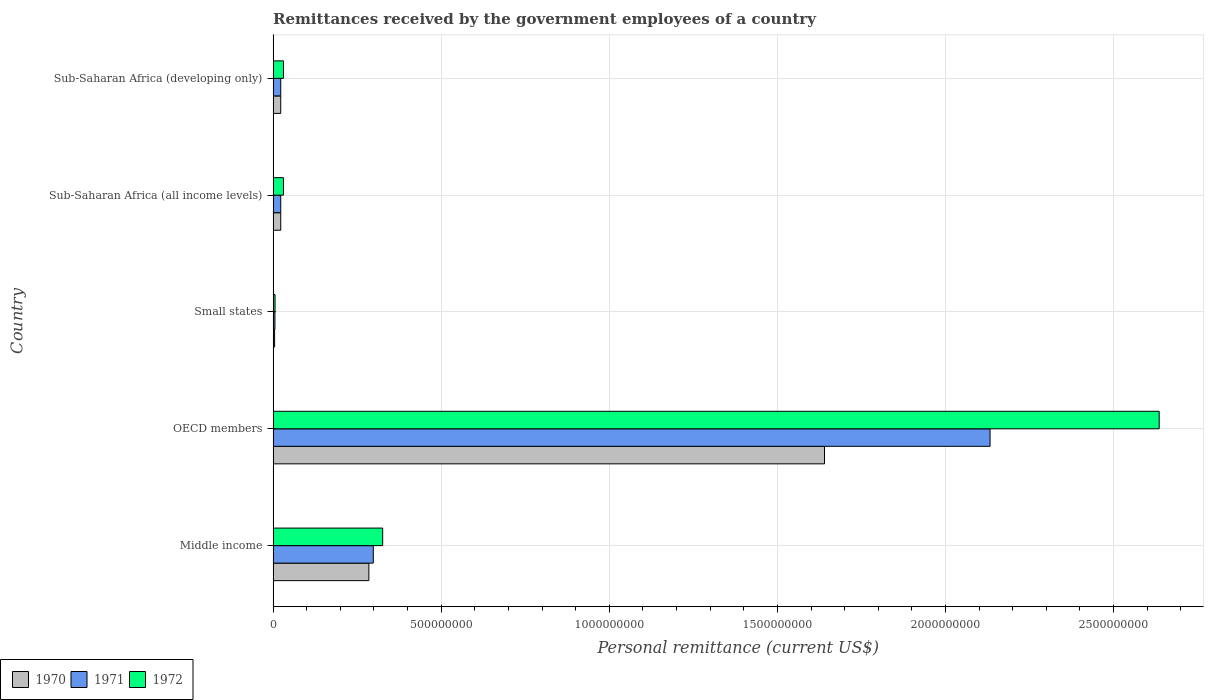How many different coloured bars are there?
Offer a very short reply. 3. Are the number of bars on each tick of the Y-axis equal?
Make the answer very short. Yes. How many bars are there on the 4th tick from the top?
Ensure brevity in your answer.  3. What is the label of the 4th group of bars from the top?
Give a very brief answer. OECD members. What is the remittances received by the government employees in 1970 in Sub-Saharan Africa (developing only)?
Your answer should be very brief. 2.27e+07. Across all countries, what is the maximum remittances received by the government employees in 1971?
Make the answer very short. 2.13e+09. Across all countries, what is the minimum remittances received by the government employees in 1972?
Make the answer very short. 5.71e+06. In which country was the remittances received by the government employees in 1972 maximum?
Offer a terse response. OECD members. In which country was the remittances received by the government employees in 1970 minimum?
Ensure brevity in your answer.  Small states. What is the total remittances received by the government employees in 1972 in the graph?
Keep it short and to the point. 3.03e+09. What is the difference between the remittances received by the government employees in 1970 in Middle income and that in Sub-Saharan Africa (developing only)?
Provide a succinct answer. 2.62e+08. What is the difference between the remittances received by the government employees in 1970 in Small states and the remittances received by the government employees in 1971 in OECD members?
Keep it short and to the point. -2.13e+09. What is the average remittances received by the government employees in 1971 per country?
Offer a very short reply. 4.96e+08. What is the difference between the remittances received by the government employees in 1970 and remittances received by the government employees in 1972 in Middle income?
Your response must be concise. -4.11e+07. In how many countries, is the remittances received by the government employees in 1972 greater than 2400000000 US$?
Provide a succinct answer. 1. What is the ratio of the remittances received by the government employees in 1970 in Middle income to that in Sub-Saharan Africa (developing only)?
Offer a terse response. 12.57. Is the remittances received by the government employees in 1972 in Small states less than that in Sub-Saharan Africa (all income levels)?
Offer a very short reply. Yes. What is the difference between the highest and the second highest remittances received by the government employees in 1971?
Your answer should be compact. 1.83e+09. What is the difference between the highest and the lowest remittances received by the government employees in 1971?
Ensure brevity in your answer.  2.13e+09. In how many countries, is the remittances received by the government employees in 1972 greater than the average remittances received by the government employees in 1972 taken over all countries?
Your answer should be very brief. 1. What does the 2nd bar from the bottom in Sub-Saharan Africa (developing only) represents?
Ensure brevity in your answer.  1971. Is it the case that in every country, the sum of the remittances received by the government employees in 1971 and remittances received by the government employees in 1972 is greater than the remittances received by the government employees in 1970?
Ensure brevity in your answer.  Yes. Are all the bars in the graph horizontal?
Provide a succinct answer. Yes. Does the graph contain grids?
Make the answer very short. Yes. What is the title of the graph?
Make the answer very short. Remittances received by the government employees of a country. Does "1975" appear as one of the legend labels in the graph?
Make the answer very short. No. What is the label or title of the X-axis?
Your answer should be compact. Personal remittance (current US$). What is the label or title of the Y-axis?
Make the answer very short. Country. What is the Personal remittance (current US$) in 1970 in Middle income?
Your answer should be very brief. 2.85e+08. What is the Personal remittance (current US$) of 1971 in Middle income?
Provide a short and direct response. 2.98e+08. What is the Personal remittance (current US$) in 1972 in Middle income?
Your answer should be very brief. 3.26e+08. What is the Personal remittance (current US$) of 1970 in OECD members?
Give a very brief answer. 1.64e+09. What is the Personal remittance (current US$) in 1971 in OECD members?
Provide a succinct answer. 2.13e+09. What is the Personal remittance (current US$) in 1972 in OECD members?
Keep it short and to the point. 2.64e+09. What is the Personal remittance (current US$) of 1970 in Small states?
Provide a succinct answer. 4.40e+06. What is the Personal remittance (current US$) of 1971 in Small states?
Keep it short and to the point. 5.40e+06. What is the Personal remittance (current US$) in 1972 in Small states?
Your response must be concise. 5.71e+06. What is the Personal remittance (current US$) in 1970 in Sub-Saharan Africa (all income levels)?
Your answer should be compact. 2.27e+07. What is the Personal remittance (current US$) of 1971 in Sub-Saharan Africa (all income levels)?
Give a very brief answer. 2.26e+07. What is the Personal remittance (current US$) in 1972 in Sub-Saharan Africa (all income levels)?
Give a very brief answer. 3.07e+07. What is the Personal remittance (current US$) of 1970 in Sub-Saharan Africa (developing only)?
Offer a terse response. 2.27e+07. What is the Personal remittance (current US$) in 1971 in Sub-Saharan Africa (developing only)?
Give a very brief answer. 2.26e+07. What is the Personal remittance (current US$) in 1972 in Sub-Saharan Africa (developing only)?
Your answer should be compact. 3.07e+07. Across all countries, what is the maximum Personal remittance (current US$) in 1970?
Provide a short and direct response. 1.64e+09. Across all countries, what is the maximum Personal remittance (current US$) in 1971?
Give a very brief answer. 2.13e+09. Across all countries, what is the maximum Personal remittance (current US$) of 1972?
Offer a terse response. 2.64e+09. Across all countries, what is the minimum Personal remittance (current US$) of 1970?
Ensure brevity in your answer.  4.40e+06. Across all countries, what is the minimum Personal remittance (current US$) in 1971?
Your response must be concise. 5.40e+06. Across all countries, what is the minimum Personal remittance (current US$) in 1972?
Keep it short and to the point. 5.71e+06. What is the total Personal remittance (current US$) in 1970 in the graph?
Keep it short and to the point. 1.97e+09. What is the total Personal remittance (current US$) in 1971 in the graph?
Provide a short and direct response. 2.48e+09. What is the total Personal remittance (current US$) in 1972 in the graph?
Make the answer very short. 3.03e+09. What is the difference between the Personal remittance (current US$) of 1970 in Middle income and that in OECD members?
Provide a short and direct response. -1.36e+09. What is the difference between the Personal remittance (current US$) in 1971 in Middle income and that in OECD members?
Your answer should be compact. -1.83e+09. What is the difference between the Personal remittance (current US$) of 1972 in Middle income and that in OECD members?
Ensure brevity in your answer.  -2.31e+09. What is the difference between the Personal remittance (current US$) in 1970 in Middle income and that in Small states?
Your answer should be very brief. 2.80e+08. What is the difference between the Personal remittance (current US$) in 1971 in Middle income and that in Small states?
Offer a very short reply. 2.93e+08. What is the difference between the Personal remittance (current US$) of 1972 in Middle income and that in Small states?
Provide a short and direct response. 3.20e+08. What is the difference between the Personal remittance (current US$) in 1970 in Middle income and that in Sub-Saharan Africa (all income levels)?
Provide a succinct answer. 2.62e+08. What is the difference between the Personal remittance (current US$) in 1971 in Middle income and that in Sub-Saharan Africa (all income levels)?
Your answer should be very brief. 2.75e+08. What is the difference between the Personal remittance (current US$) of 1972 in Middle income and that in Sub-Saharan Africa (all income levels)?
Make the answer very short. 2.95e+08. What is the difference between the Personal remittance (current US$) of 1970 in Middle income and that in Sub-Saharan Africa (developing only)?
Keep it short and to the point. 2.62e+08. What is the difference between the Personal remittance (current US$) of 1971 in Middle income and that in Sub-Saharan Africa (developing only)?
Keep it short and to the point. 2.75e+08. What is the difference between the Personal remittance (current US$) of 1972 in Middle income and that in Sub-Saharan Africa (developing only)?
Give a very brief answer. 2.95e+08. What is the difference between the Personal remittance (current US$) of 1970 in OECD members and that in Small states?
Provide a short and direct response. 1.64e+09. What is the difference between the Personal remittance (current US$) in 1971 in OECD members and that in Small states?
Make the answer very short. 2.13e+09. What is the difference between the Personal remittance (current US$) of 1972 in OECD members and that in Small states?
Provide a succinct answer. 2.63e+09. What is the difference between the Personal remittance (current US$) in 1970 in OECD members and that in Sub-Saharan Africa (all income levels)?
Make the answer very short. 1.62e+09. What is the difference between the Personal remittance (current US$) of 1971 in OECD members and that in Sub-Saharan Africa (all income levels)?
Offer a very short reply. 2.11e+09. What is the difference between the Personal remittance (current US$) in 1972 in OECD members and that in Sub-Saharan Africa (all income levels)?
Keep it short and to the point. 2.60e+09. What is the difference between the Personal remittance (current US$) in 1970 in OECD members and that in Sub-Saharan Africa (developing only)?
Your answer should be compact. 1.62e+09. What is the difference between the Personal remittance (current US$) in 1971 in OECD members and that in Sub-Saharan Africa (developing only)?
Make the answer very short. 2.11e+09. What is the difference between the Personal remittance (current US$) of 1972 in OECD members and that in Sub-Saharan Africa (developing only)?
Make the answer very short. 2.60e+09. What is the difference between the Personal remittance (current US$) of 1970 in Small states and that in Sub-Saharan Africa (all income levels)?
Your answer should be very brief. -1.83e+07. What is the difference between the Personal remittance (current US$) of 1971 in Small states and that in Sub-Saharan Africa (all income levels)?
Ensure brevity in your answer.  -1.72e+07. What is the difference between the Personal remittance (current US$) in 1972 in Small states and that in Sub-Saharan Africa (all income levels)?
Make the answer very short. -2.50e+07. What is the difference between the Personal remittance (current US$) in 1970 in Small states and that in Sub-Saharan Africa (developing only)?
Offer a very short reply. -1.83e+07. What is the difference between the Personal remittance (current US$) of 1971 in Small states and that in Sub-Saharan Africa (developing only)?
Make the answer very short. -1.72e+07. What is the difference between the Personal remittance (current US$) of 1972 in Small states and that in Sub-Saharan Africa (developing only)?
Offer a terse response. -2.50e+07. What is the difference between the Personal remittance (current US$) in 1971 in Sub-Saharan Africa (all income levels) and that in Sub-Saharan Africa (developing only)?
Make the answer very short. 0. What is the difference between the Personal remittance (current US$) of 1970 in Middle income and the Personal remittance (current US$) of 1971 in OECD members?
Keep it short and to the point. -1.85e+09. What is the difference between the Personal remittance (current US$) in 1970 in Middle income and the Personal remittance (current US$) in 1972 in OECD members?
Offer a very short reply. -2.35e+09. What is the difference between the Personal remittance (current US$) of 1971 in Middle income and the Personal remittance (current US$) of 1972 in OECD members?
Your answer should be compact. -2.34e+09. What is the difference between the Personal remittance (current US$) in 1970 in Middle income and the Personal remittance (current US$) in 1971 in Small states?
Give a very brief answer. 2.79e+08. What is the difference between the Personal remittance (current US$) of 1970 in Middle income and the Personal remittance (current US$) of 1972 in Small states?
Your answer should be compact. 2.79e+08. What is the difference between the Personal remittance (current US$) in 1971 in Middle income and the Personal remittance (current US$) in 1972 in Small states?
Keep it short and to the point. 2.92e+08. What is the difference between the Personal remittance (current US$) of 1970 in Middle income and the Personal remittance (current US$) of 1971 in Sub-Saharan Africa (all income levels)?
Your answer should be very brief. 2.62e+08. What is the difference between the Personal remittance (current US$) in 1970 in Middle income and the Personal remittance (current US$) in 1972 in Sub-Saharan Africa (all income levels)?
Your response must be concise. 2.54e+08. What is the difference between the Personal remittance (current US$) in 1971 in Middle income and the Personal remittance (current US$) in 1972 in Sub-Saharan Africa (all income levels)?
Ensure brevity in your answer.  2.67e+08. What is the difference between the Personal remittance (current US$) in 1970 in Middle income and the Personal remittance (current US$) in 1971 in Sub-Saharan Africa (developing only)?
Keep it short and to the point. 2.62e+08. What is the difference between the Personal remittance (current US$) of 1970 in Middle income and the Personal remittance (current US$) of 1972 in Sub-Saharan Africa (developing only)?
Provide a succinct answer. 2.54e+08. What is the difference between the Personal remittance (current US$) of 1971 in Middle income and the Personal remittance (current US$) of 1972 in Sub-Saharan Africa (developing only)?
Your response must be concise. 2.67e+08. What is the difference between the Personal remittance (current US$) in 1970 in OECD members and the Personal remittance (current US$) in 1971 in Small states?
Provide a short and direct response. 1.63e+09. What is the difference between the Personal remittance (current US$) in 1970 in OECD members and the Personal remittance (current US$) in 1972 in Small states?
Provide a succinct answer. 1.63e+09. What is the difference between the Personal remittance (current US$) in 1971 in OECD members and the Personal remittance (current US$) in 1972 in Small states?
Provide a short and direct response. 2.13e+09. What is the difference between the Personal remittance (current US$) in 1970 in OECD members and the Personal remittance (current US$) in 1971 in Sub-Saharan Africa (all income levels)?
Your response must be concise. 1.62e+09. What is the difference between the Personal remittance (current US$) of 1970 in OECD members and the Personal remittance (current US$) of 1972 in Sub-Saharan Africa (all income levels)?
Your response must be concise. 1.61e+09. What is the difference between the Personal remittance (current US$) of 1971 in OECD members and the Personal remittance (current US$) of 1972 in Sub-Saharan Africa (all income levels)?
Ensure brevity in your answer.  2.10e+09. What is the difference between the Personal remittance (current US$) of 1970 in OECD members and the Personal remittance (current US$) of 1971 in Sub-Saharan Africa (developing only)?
Your answer should be very brief. 1.62e+09. What is the difference between the Personal remittance (current US$) of 1970 in OECD members and the Personal remittance (current US$) of 1972 in Sub-Saharan Africa (developing only)?
Make the answer very short. 1.61e+09. What is the difference between the Personal remittance (current US$) of 1971 in OECD members and the Personal remittance (current US$) of 1972 in Sub-Saharan Africa (developing only)?
Make the answer very short. 2.10e+09. What is the difference between the Personal remittance (current US$) in 1970 in Small states and the Personal remittance (current US$) in 1971 in Sub-Saharan Africa (all income levels)?
Give a very brief answer. -1.82e+07. What is the difference between the Personal remittance (current US$) of 1970 in Small states and the Personal remittance (current US$) of 1972 in Sub-Saharan Africa (all income levels)?
Give a very brief answer. -2.63e+07. What is the difference between the Personal remittance (current US$) of 1971 in Small states and the Personal remittance (current US$) of 1972 in Sub-Saharan Africa (all income levels)?
Offer a terse response. -2.53e+07. What is the difference between the Personal remittance (current US$) in 1970 in Small states and the Personal remittance (current US$) in 1971 in Sub-Saharan Africa (developing only)?
Offer a terse response. -1.82e+07. What is the difference between the Personal remittance (current US$) in 1970 in Small states and the Personal remittance (current US$) in 1972 in Sub-Saharan Africa (developing only)?
Your answer should be compact. -2.63e+07. What is the difference between the Personal remittance (current US$) of 1971 in Small states and the Personal remittance (current US$) of 1972 in Sub-Saharan Africa (developing only)?
Your answer should be very brief. -2.53e+07. What is the difference between the Personal remittance (current US$) of 1970 in Sub-Saharan Africa (all income levels) and the Personal remittance (current US$) of 1971 in Sub-Saharan Africa (developing only)?
Your answer should be compact. 2.18e+04. What is the difference between the Personal remittance (current US$) in 1970 in Sub-Saharan Africa (all income levels) and the Personal remittance (current US$) in 1972 in Sub-Saharan Africa (developing only)?
Make the answer very short. -8.07e+06. What is the difference between the Personal remittance (current US$) in 1971 in Sub-Saharan Africa (all income levels) and the Personal remittance (current US$) in 1972 in Sub-Saharan Africa (developing only)?
Offer a terse response. -8.09e+06. What is the average Personal remittance (current US$) of 1970 per country?
Give a very brief answer. 3.95e+08. What is the average Personal remittance (current US$) in 1971 per country?
Your answer should be very brief. 4.96e+08. What is the average Personal remittance (current US$) in 1972 per country?
Keep it short and to the point. 6.06e+08. What is the difference between the Personal remittance (current US$) of 1970 and Personal remittance (current US$) of 1971 in Middle income?
Make the answer very short. -1.32e+07. What is the difference between the Personal remittance (current US$) of 1970 and Personal remittance (current US$) of 1972 in Middle income?
Offer a terse response. -4.11e+07. What is the difference between the Personal remittance (current US$) in 1971 and Personal remittance (current US$) in 1972 in Middle income?
Give a very brief answer. -2.79e+07. What is the difference between the Personal remittance (current US$) in 1970 and Personal remittance (current US$) in 1971 in OECD members?
Offer a terse response. -4.92e+08. What is the difference between the Personal remittance (current US$) in 1970 and Personal remittance (current US$) in 1972 in OECD members?
Provide a succinct answer. -9.96e+08. What is the difference between the Personal remittance (current US$) of 1971 and Personal remittance (current US$) of 1972 in OECD members?
Offer a very short reply. -5.03e+08. What is the difference between the Personal remittance (current US$) in 1970 and Personal remittance (current US$) in 1971 in Small states?
Make the answer very short. -1.00e+06. What is the difference between the Personal remittance (current US$) in 1970 and Personal remittance (current US$) in 1972 in Small states?
Give a very brief answer. -1.31e+06. What is the difference between the Personal remittance (current US$) in 1971 and Personal remittance (current US$) in 1972 in Small states?
Give a very brief answer. -3.07e+05. What is the difference between the Personal remittance (current US$) in 1970 and Personal remittance (current US$) in 1971 in Sub-Saharan Africa (all income levels)?
Your answer should be very brief. 2.18e+04. What is the difference between the Personal remittance (current US$) of 1970 and Personal remittance (current US$) of 1972 in Sub-Saharan Africa (all income levels)?
Offer a terse response. -8.07e+06. What is the difference between the Personal remittance (current US$) in 1971 and Personal remittance (current US$) in 1972 in Sub-Saharan Africa (all income levels)?
Provide a short and direct response. -8.09e+06. What is the difference between the Personal remittance (current US$) in 1970 and Personal remittance (current US$) in 1971 in Sub-Saharan Africa (developing only)?
Give a very brief answer. 2.18e+04. What is the difference between the Personal remittance (current US$) of 1970 and Personal remittance (current US$) of 1972 in Sub-Saharan Africa (developing only)?
Ensure brevity in your answer.  -8.07e+06. What is the difference between the Personal remittance (current US$) of 1971 and Personal remittance (current US$) of 1972 in Sub-Saharan Africa (developing only)?
Offer a terse response. -8.09e+06. What is the ratio of the Personal remittance (current US$) of 1970 in Middle income to that in OECD members?
Provide a short and direct response. 0.17. What is the ratio of the Personal remittance (current US$) of 1971 in Middle income to that in OECD members?
Give a very brief answer. 0.14. What is the ratio of the Personal remittance (current US$) in 1972 in Middle income to that in OECD members?
Ensure brevity in your answer.  0.12. What is the ratio of the Personal remittance (current US$) of 1970 in Middle income to that in Small states?
Keep it short and to the point. 64.72. What is the ratio of the Personal remittance (current US$) of 1971 in Middle income to that in Small states?
Provide a succinct answer. 55.17. What is the ratio of the Personal remittance (current US$) in 1972 in Middle income to that in Small states?
Keep it short and to the point. 57.08. What is the ratio of the Personal remittance (current US$) of 1970 in Middle income to that in Sub-Saharan Africa (all income levels)?
Keep it short and to the point. 12.57. What is the ratio of the Personal remittance (current US$) of 1971 in Middle income to that in Sub-Saharan Africa (all income levels)?
Give a very brief answer. 13.16. What is the ratio of the Personal remittance (current US$) of 1972 in Middle income to that in Sub-Saharan Africa (all income levels)?
Your answer should be compact. 10.6. What is the ratio of the Personal remittance (current US$) of 1970 in Middle income to that in Sub-Saharan Africa (developing only)?
Your answer should be very brief. 12.57. What is the ratio of the Personal remittance (current US$) of 1971 in Middle income to that in Sub-Saharan Africa (developing only)?
Offer a terse response. 13.16. What is the ratio of the Personal remittance (current US$) of 1972 in Middle income to that in Sub-Saharan Africa (developing only)?
Provide a short and direct response. 10.6. What is the ratio of the Personal remittance (current US$) in 1970 in OECD members to that in Small states?
Make the answer very short. 372.75. What is the ratio of the Personal remittance (current US$) in 1971 in OECD members to that in Small states?
Your response must be concise. 394.8. What is the ratio of the Personal remittance (current US$) of 1972 in OECD members to that in Small states?
Ensure brevity in your answer.  461.7. What is the ratio of the Personal remittance (current US$) of 1970 in OECD members to that in Sub-Saharan Africa (all income levels)?
Offer a terse response. 72.38. What is the ratio of the Personal remittance (current US$) in 1971 in OECD members to that in Sub-Saharan Africa (all income levels)?
Provide a succinct answer. 94.2. What is the ratio of the Personal remittance (current US$) of 1972 in OECD members to that in Sub-Saharan Africa (all income levels)?
Ensure brevity in your answer.  85.76. What is the ratio of the Personal remittance (current US$) of 1970 in OECD members to that in Sub-Saharan Africa (developing only)?
Keep it short and to the point. 72.38. What is the ratio of the Personal remittance (current US$) in 1971 in OECD members to that in Sub-Saharan Africa (developing only)?
Your response must be concise. 94.2. What is the ratio of the Personal remittance (current US$) of 1972 in OECD members to that in Sub-Saharan Africa (developing only)?
Provide a succinct answer. 85.76. What is the ratio of the Personal remittance (current US$) of 1970 in Small states to that in Sub-Saharan Africa (all income levels)?
Provide a short and direct response. 0.19. What is the ratio of the Personal remittance (current US$) in 1971 in Small states to that in Sub-Saharan Africa (all income levels)?
Your answer should be very brief. 0.24. What is the ratio of the Personal remittance (current US$) of 1972 in Small states to that in Sub-Saharan Africa (all income levels)?
Ensure brevity in your answer.  0.19. What is the ratio of the Personal remittance (current US$) in 1970 in Small states to that in Sub-Saharan Africa (developing only)?
Provide a succinct answer. 0.19. What is the ratio of the Personal remittance (current US$) of 1971 in Small states to that in Sub-Saharan Africa (developing only)?
Ensure brevity in your answer.  0.24. What is the ratio of the Personal remittance (current US$) of 1972 in Small states to that in Sub-Saharan Africa (developing only)?
Offer a terse response. 0.19. What is the ratio of the Personal remittance (current US$) in 1970 in Sub-Saharan Africa (all income levels) to that in Sub-Saharan Africa (developing only)?
Make the answer very short. 1. What is the ratio of the Personal remittance (current US$) of 1971 in Sub-Saharan Africa (all income levels) to that in Sub-Saharan Africa (developing only)?
Give a very brief answer. 1. What is the ratio of the Personal remittance (current US$) in 1972 in Sub-Saharan Africa (all income levels) to that in Sub-Saharan Africa (developing only)?
Provide a short and direct response. 1. What is the difference between the highest and the second highest Personal remittance (current US$) in 1970?
Your response must be concise. 1.36e+09. What is the difference between the highest and the second highest Personal remittance (current US$) in 1971?
Give a very brief answer. 1.83e+09. What is the difference between the highest and the second highest Personal remittance (current US$) of 1972?
Provide a short and direct response. 2.31e+09. What is the difference between the highest and the lowest Personal remittance (current US$) of 1970?
Your response must be concise. 1.64e+09. What is the difference between the highest and the lowest Personal remittance (current US$) of 1971?
Your response must be concise. 2.13e+09. What is the difference between the highest and the lowest Personal remittance (current US$) of 1972?
Offer a terse response. 2.63e+09. 